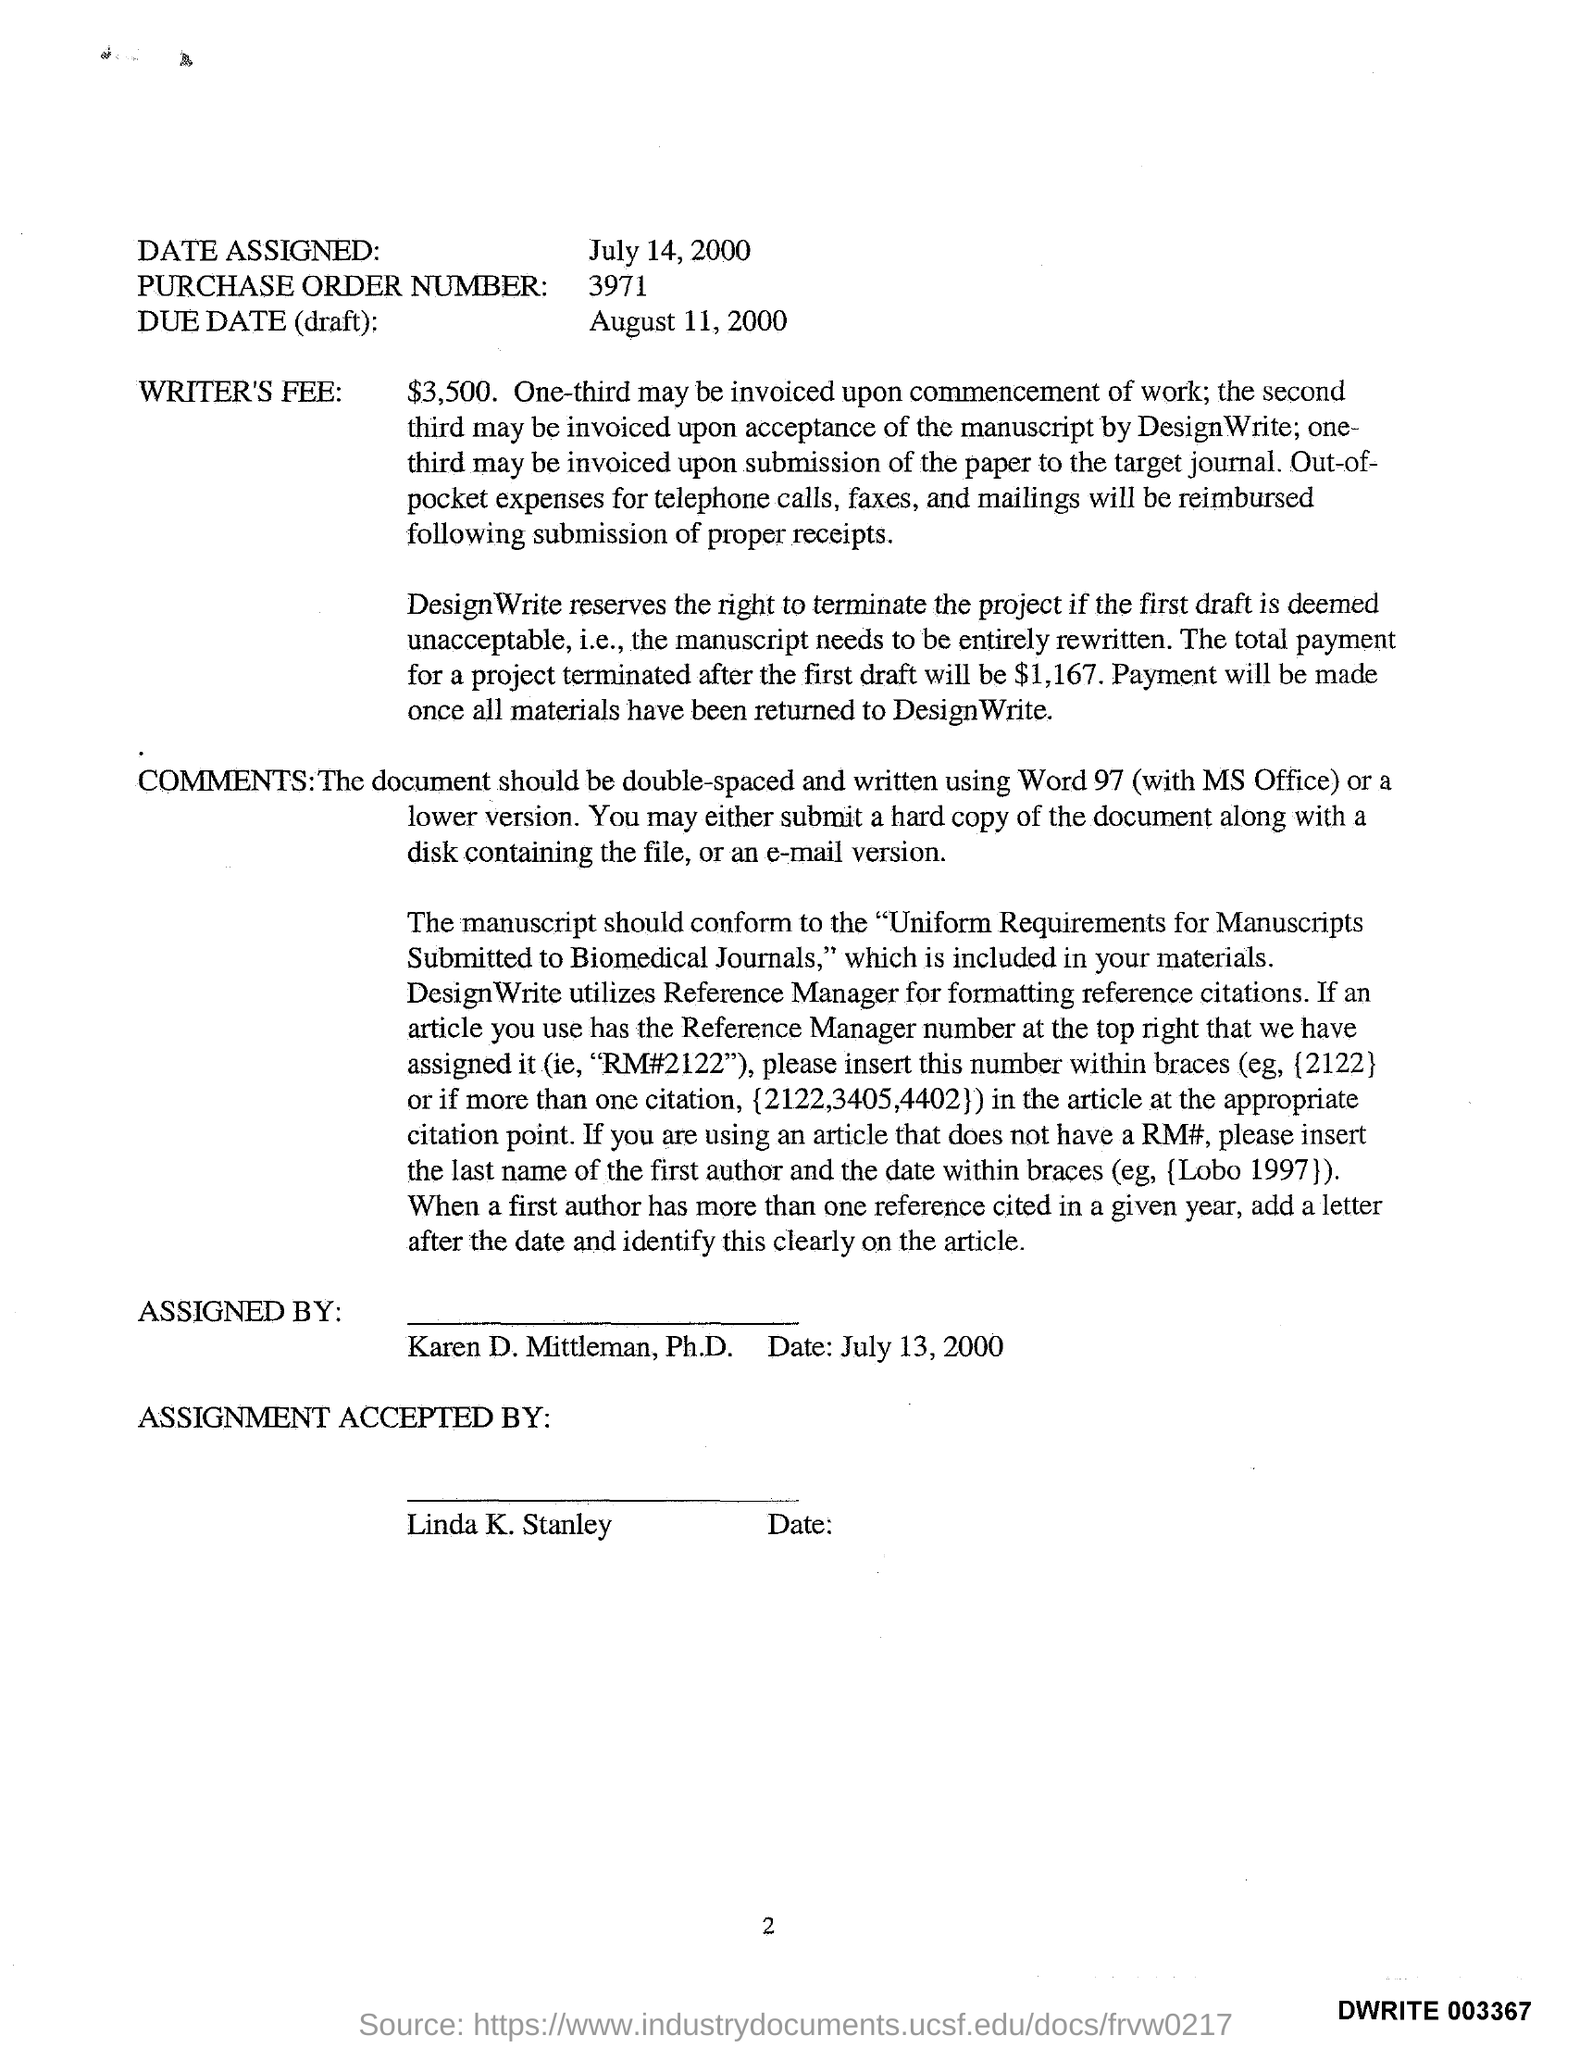Draw attention to some important aspects in this diagram. The writer's fee mentioned in the given letter is $3,500. The name written under the "Assigned by" column in the given letter is "Karen D. Mittleman, Ph.D. Linda K. Stanley accepted the assignment as stated in the given letter. 